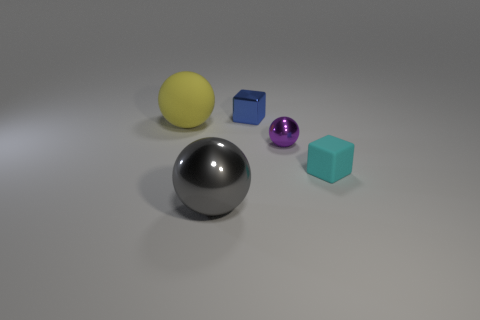Subtract all big spheres. How many spheres are left? 1 Add 4 red metal cylinders. How many objects exist? 9 Subtract 1 spheres. How many spheres are left? 2 Subtract all red balls. Subtract all red cylinders. How many balls are left? 3 Add 2 metal blocks. How many metal blocks are left? 3 Add 2 large matte balls. How many large matte balls exist? 3 Subtract 0 brown spheres. How many objects are left? 5 Subtract all cubes. How many objects are left? 3 Subtract all small rubber spheres. Subtract all small cubes. How many objects are left? 3 